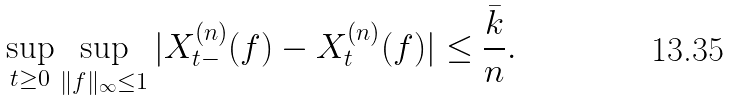Convert formula to latex. <formula><loc_0><loc_0><loc_500><loc_500>\sup _ { t \geq 0 } \sup _ { \| f \| _ { \infty } \leq 1 } | X ^ { ( n ) } _ { t - } ( f ) - X ^ { ( n ) } _ { t } ( f ) | \leq \frac { \bar { k } } { n } .</formula> 